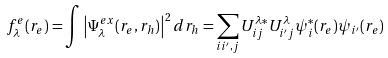Convert formula to latex. <formula><loc_0><loc_0><loc_500><loc_500>f ^ { e } _ { \lambda } ( { r } _ { e } ) = \int \left | \Psi ^ { e x } _ { \lambda } ( { r } _ { e } , { r } _ { h } ) \right | ^ { 2 } d { r } _ { h } = \sum _ { i i ^ { \prime } , j } U ^ { \lambda * } _ { i j } U ^ { \lambda } _ { i ^ { \prime } j } \psi ^ { * } _ { i } ( { r } _ { e } ) \psi _ { i ^ { \prime } } ( { r } _ { e } )</formula> 